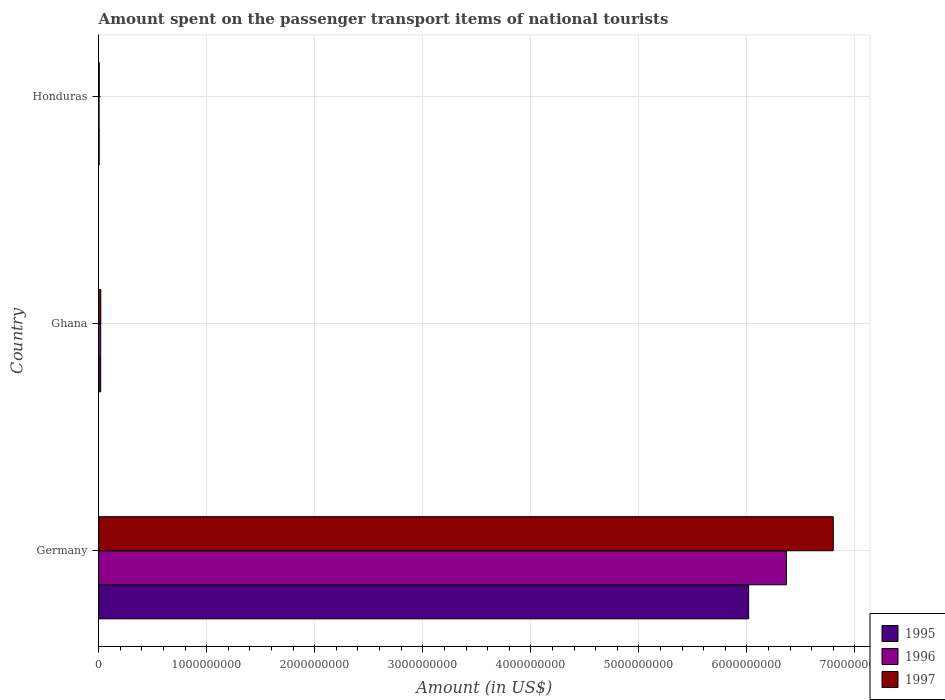How many different coloured bars are there?
Your response must be concise. 3. How many groups of bars are there?
Ensure brevity in your answer.  3. Are the number of bars per tick equal to the number of legend labels?
Offer a very short reply. Yes. How many bars are there on the 2nd tick from the top?
Provide a short and direct response. 3. What is the label of the 3rd group of bars from the top?
Give a very brief answer. Germany. Across all countries, what is the maximum amount spent on the passenger transport items of national tourists in 1996?
Provide a succinct answer. 6.37e+09. In which country was the amount spent on the passenger transport items of national tourists in 1997 maximum?
Offer a very short reply. Germany. In which country was the amount spent on the passenger transport items of national tourists in 1995 minimum?
Give a very brief answer. Honduras. What is the total amount spent on the passenger transport items of national tourists in 1997 in the graph?
Your answer should be very brief. 6.82e+09. What is the difference between the amount spent on the passenger transport items of national tourists in 1997 in Ghana and that in Honduras?
Ensure brevity in your answer.  1.40e+07. What is the difference between the amount spent on the passenger transport items of national tourists in 1996 in Ghana and the amount spent on the passenger transport items of national tourists in 1997 in Germany?
Your answer should be compact. -6.78e+09. What is the average amount spent on the passenger transport items of national tourists in 1996 per country?
Provide a succinct answer. 2.13e+09. What is the difference between the amount spent on the passenger transport items of national tourists in 1995 and amount spent on the passenger transport items of national tourists in 1996 in Germany?
Provide a succinct answer. -3.50e+08. In how many countries, is the amount spent on the passenger transport items of national tourists in 1995 greater than 4800000000 US$?
Keep it short and to the point. 1. What is the ratio of the amount spent on the passenger transport items of national tourists in 1995 in Germany to that in Honduras?
Make the answer very short. 1203.2. Is the difference between the amount spent on the passenger transport items of national tourists in 1995 in Germany and Honduras greater than the difference between the amount spent on the passenger transport items of national tourists in 1996 in Germany and Honduras?
Make the answer very short. No. What is the difference between the highest and the second highest amount spent on the passenger transport items of national tourists in 1996?
Give a very brief answer. 6.35e+09. What is the difference between the highest and the lowest amount spent on the passenger transport items of national tourists in 1995?
Keep it short and to the point. 6.01e+09. Is the sum of the amount spent on the passenger transport items of national tourists in 1996 in Germany and Honduras greater than the maximum amount spent on the passenger transport items of national tourists in 1997 across all countries?
Give a very brief answer. No. What does the 3rd bar from the top in Germany represents?
Ensure brevity in your answer.  1995. What does the 3rd bar from the bottom in Honduras represents?
Ensure brevity in your answer.  1997. Are all the bars in the graph horizontal?
Keep it short and to the point. Yes. What is the difference between two consecutive major ticks on the X-axis?
Your response must be concise. 1.00e+09. How are the legend labels stacked?
Your answer should be very brief. Vertical. What is the title of the graph?
Give a very brief answer. Amount spent on the passenger transport items of national tourists. What is the label or title of the Y-axis?
Your answer should be compact. Country. What is the Amount (in US$) in 1995 in Germany?
Offer a terse response. 6.02e+09. What is the Amount (in US$) of 1996 in Germany?
Give a very brief answer. 6.37e+09. What is the Amount (in US$) in 1997 in Germany?
Offer a very short reply. 6.80e+09. What is the Amount (in US$) in 1995 in Ghana?
Provide a short and direct response. 1.90e+07. What is the Amount (in US$) in 1996 in Ghana?
Give a very brief answer. 1.90e+07. What is the Amount (in US$) of 1997 in Ghana?
Provide a succinct answer. 2.00e+07. What is the Amount (in US$) in 1995 in Honduras?
Ensure brevity in your answer.  5.00e+06. What is the Amount (in US$) in 1996 in Honduras?
Offer a terse response. 4.00e+06. Across all countries, what is the maximum Amount (in US$) of 1995?
Your response must be concise. 6.02e+09. Across all countries, what is the maximum Amount (in US$) of 1996?
Offer a terse response. 6.37e+09. Across all countries, what is the maximum Amount (in US$) in 1997?
Keep it short and to the point. 6.80e+09. Across all countries, what is the minimum Amount (in US$) of 1997?
Offer a terse response. 6.00e+06. What is the total Amount (in US$) of 1995 in the graph?
Your answer should be very brief. 6.04e+09. What is the total Amount (in US$) of 1996 in the graph?
Provide a succinct answer. 6.39e+09. What is the total Amount (in US$) of 1997 in the graph?
Your answer should be very brief. 6.82e+09. What is the difference between the Amount (in US$) of 1995 in Germany and that in Ghana?
Provide a short and direct response. 6.00e+09. What is the difference between the Amount (in US$) of 1996 in Germany and that in Ghana?
Your answer should be compact. 6.35e+09. What is the difference between the Amount (in US$) of 1997 in Germany and that in Ghana?
Provide a short and direct response. 6.78e+09. What is the difference between the Amount (in US$) in 1995 in Germany and that in Honduras?
Your response must be concise. 6.01e+09. What is the difference between the Amount (in US$) in 1996 in Germany and that in Honduras?
Your answer should be compact. 6.36e+09. What is the difference between the Amount (in US$) in 1997 in Germany and that in Honduras?
Your answer should be very brief. 6.79e+09. What is the difference between the Amount (in US$) of 1995 in Ghana and that in Honduras?
Provide a succinct answer. 1.40e+07. What is the difference between the Amount (in US$) in 1996 in Ghana and that in Honduras?
Offer a terse response. 1.50e+07. What is the difference between the Amount (in US$) in 1997 in Ghana and that in Honduras?
Provide a succinct answer. 1.40e+07. What is the difference between the Amount (in US$) in 1995 in Germany and the Amount (in US$) in 1996 in Ghana?
Offer a terse response. 6.00e+09. What is the difference between the Amount (in US$) of 1995 in Germany and the Amount (in US$) of 1997 in Ghana?
Keep it short and to the point. 6.00e+09. What is the difference between the Amount (in US$) of 1996 in Germany and the Amount (in US$) of 1997 in Ghana?
Keep it short and to the point. 6.35e+09. What is the difference between the Amount (in US$) in 1995 in Germany and the Amount (in US$) in 1996 in Honduras?
Give a very brief answer. 6.01e+09. What is the difference between the Amount (in US$) in 1995 in Germany and the Amount (in US$) in 1997 in Honduras?
Offer a terse response. 6.01e+09. What is the difference between the Amount (in US$) of 1996 in Germany and the Amount (in US$) of 1997 in Honduras?
Your response must be concise. 6.36e+09. What is the difference between the Amount (in US$) of 1995 in Ghana and the Amount (in US$) of 1996 in Honduras?
Give a very brief answer. 1.50e+07. What is the difference between the Amount (in US$) of 1995 in Ghana and the Amount (in US$) of 1997 in Honduras?
Offer a very short reply. 1.30e+07. What is the difference between the Amount (in US$) in 1996 in Ghana and the Amount (in US$) in 1997 in Honduras?
Provide a succinct answer. 1.30e+07. What is the average Amount (in US$) of 1995 per country?
Keep it short and to the point. 2.01e+09. What is the average Amount (in US$) in 1996 per country?
Ensure brevity in your answer.  2.13e+09. What is the average Amount (in US$) of 1997 per country?
Your answer should be very brief. 2.28e+09. What is the difference between the Amount (in US$) in 1995 and Amount (in US$) in 1996 in Germany?
Provide a short and direct response. -3.50e+08. What is the difference between the Amount (in US$) in 1995 and Amount (in US$) in 1997 in Germany?
Your answer should be very brief. -7.83e+08. What is the difference between the Amount (in US$) in 1996 and Amount (in US$) in 1997 in Germany?
Offer a terse response. -4.33e+08. What is the difference between the Amount (in US$) of 1995 and Amount (in US$) of 1996 in Ghana?
Make the answer very short. 0. What is the ratio of the Amount (in US$) of 1995 in Germany to that in Ghana?
Give a very brief answer. 316.63. What is the ratio of the Amount (in US$) of 1996 in Germany to that in Ghana?
Your answer should be compact. 335.05. What is the ratio of the Amount (in US$) of 1997 in Germany to that in Ghana?
Ensure brevity in your answer.  339.95. What is the ratio of the Amount (in US$) of 1995 in Germany to that in Honduras?
Make the answer very short. 1203.2. What is the ratio of the Amount (in US$) in 1996 in Germany to that in Honduras?
Ensure brevity in your answer.  1591.5. What is the ratio of the Amount (in US$) of 1997 in Germany to that in Honduras?
Ensure brevity in your answer.  1133.17. What is the ratio of the Amount (in US$) of 1995 in Ghana to that in Honduras?
Your answer should be very brief. 3.8. What is the ratio of the Amount (in US$) of 1996 in Ghana to that in Honduras?
Provide a short and direct response. 4.75. What is the difference between the highest and the second highest Amount (in US$) of 1995?
Offer a very short reply. 6.00e+09. What is the difference between the highest and the second highest Amount (in US$) of 1996?
Keep it short and to the point. 6.35e+09. What is the difference between the highest and the second highest Amount (in US$) of 1997?
Give a very brief answer. 6.78e+09. What is the difference between the highest and the lowest Amount (in US$) in 1995?
Ensure brevity in your answer.  6.01e+09. What is the difference between the highest and the lowest Amount (in US$) in 1996?
Offer a terse response. 6.36e+09. What is the difference between the highest and the lowest Amount (in US$) in 1997?
Offer a terse response. 6.79e+09. 